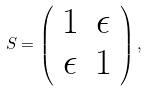<formula> <loc_0><loc_0><loc_500><loc_500>S = \left ( \begin{array} { c c } 1 & \epsilon \\ \epsilon & 1 \end{array} \right ) ,</formula> 